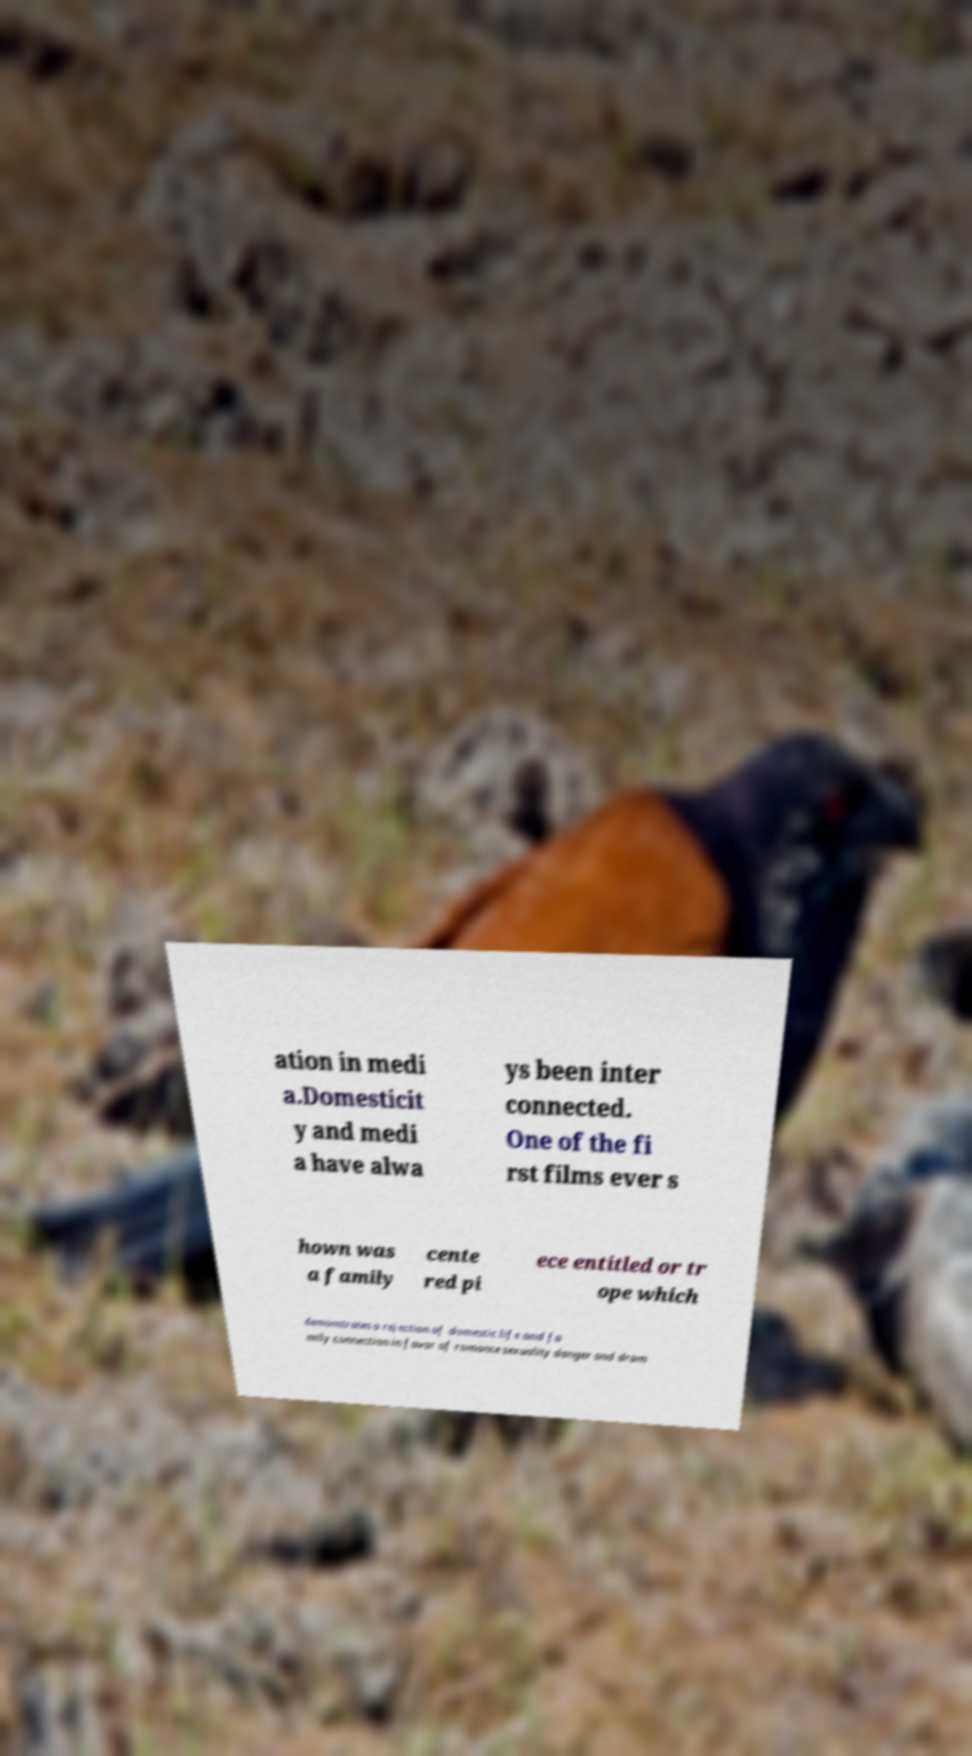I need the written content from this picture converted into text. Can you do that? ation in medi a.Domesticit y and medi a have alwa ys been inter connected. One of the fi rst films ever s hown was a family cente red pi ece entitled or tr ope which demonstrates a rejection of domestic life and fa mily connection in favor of romance sexuality danger and dram 